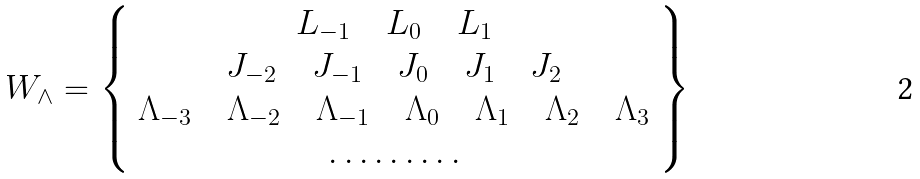<formula> <loc_0><loc_0><loc_500><loc_500>W _ { \wedge } = \left \{ \begin{array} { c } { { L _ { - 1 } \quad L _ { 0 } \quad L _ { 1 } } } \\ { { J _ { - 2 } \quad J _ { - 1 } \quad J _ { 0 } \quad J _ { 1 } \quad J _ { 2 } } } \\ { { \Lambda _ { - 3 } \quad \Lambda _ { - 2 } \quad \Lambda _ { - 1 } \quad \Lambda _ { 0 } \quad \Lambda _ { 1 } \quad \Lambda _ { 2 } \quad \Lambda _ { 3 } } } \\ { \dots \dots \dots } \end{array} \right \}</formula> 